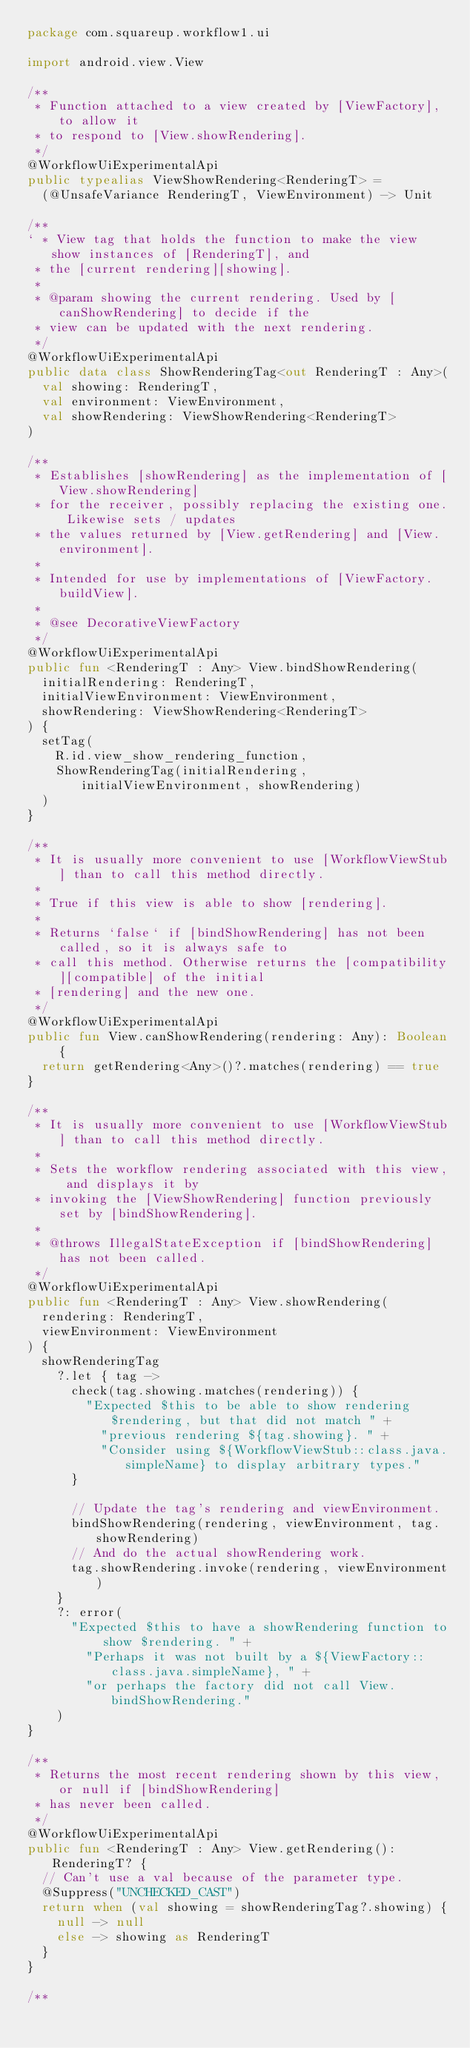Convert code to text. <code><loc_0><loc_0><loc_500><loc_500><_Kotlin_>package com.squareup.workflow1.ui

import android.view.View

/**
 * Function attached to a view created by [ViewFactory], to allow it
 * to respond to [View.showRendering].
 */
@WorkflowUiExperimentalApi
public typealias ViewShowRendering<RenderingT> =
  (@UnsafeVariance RenderingT, ViewEnvironment) -> Unit

/**
` * View tag that holds the function to make the view show instances of [RenderingT], and
 * the [current rendering][showing].
 *
 * @param showing the current rendering. Used by [canShowRendering] to decide if the
 * view can be updated with the next rendering.
 */
@WorkflowUiExperimentalApi
public data class ShowRenderingTag<out RenderingT : Any>(
  val showing: RenderingT,
  val environment: ViewEnvironment,
  val showRendering: ViewShowRendering<RenderingT>
)

/**
 * Establishes [showRendering] as the implementation of [View.showRendering]
 * for the receiver, possibly replacing the existing one. Likewise sets / updates
 * the values returned by [View.getRendering] and [View.environment].
 *
 * Intended for use by implementations of [ViewFactory.buildView].
 *
 * @see DecorativeViewFactory
 */
@WorkflowUiExperimentalApi
public fun <RenderingT : Any> View.bindShowRendering(
  initialRendering: RenderingT,
  initialViewEnvironment: ViewEnvironment,
  showRendering: ViewShowRendering<RenderingT>
) {
  setTag(
    R.id.view_show_rendering_function,
    ShowRenderingTag(initialRendering, initialViewEnvironment, showRendering)
  )
}

/**
 * It is usually more convenient to use [WorkflowViewStub] than to call this method directly.
 *
 * True if this view is able to show [rendering].
 *
 * Returns `false` if [bindShowRendering] has not been called, so it is always safe to
 * call this method. Otherwise returns the [compatibility][compatible] of the initial
 * [rendering] and the new one.
 */
@WorkflowUiExperimentalApi
public fun View.canShowRendering(rendering: Any): Boolean {
  return getRendering<Any>()?.matches(rendering) == true
}

/**
 * It is usually more convenient to use [WorkflowViewStub] than to call this method directly.
 *
 * Sets the workflow rendering associated with this view, and displays it by
 * invoking the [ViewShowRendering] function previously set by [bindShowRendering].
 *
 * @throws IllegalStateException if [bindShowRendering] has not been called.
 */
@WorkflowUiExperimentalApi
public fun <RenderingT : Any> View.showRendering(
  rendering: RenderingT,
  viewEnvironment: ViewEnvironment
) {
  showRenderingTag
    ?.let { tag ->
      check(tag.showing.matches(rendering)) {
        "Expected $this to be able to show rendering $rendering, but that did not match " +
          "previous rendering ${tag.showing}. " +
          "Consider using ${WorkflowViewStub::class.java.simpleName} to display arbitrary types."
      }

      // Update the tag's rendering and viewEnvironment.
      bindShowRendering(rendering, viewEnvironment, tag.showRendering)
      // And do the actual showRendering work.
      tag.showRendering.invoke(rendering, viewEnvironment)
    }
    ?: error(
      "Expected $this to have a showRendering function to show $rendering. " +
        "Perhaps it was not built by a ${ViewFactory::class.java.simpleName}, " +
        "or perhaps the factory did not call View.bindShowRendering."
    )
}

/**
 * Returns the most recent rendering shown by this view, or null if [bindShowRendering]
 * has never been called.
 */
@WorkflowUiExperimentalApi
public fun <RenderingT : Any> View.getRendering(): RenderingT? {
  // Can't use a val because of the parameter type.
  @Suppress("UNCHECKED_CAST")
  return when (val showing = showRenderingTag?.showing) {
    null -> null
    else -> showing as RenderingT
  }
}

/**</code> 